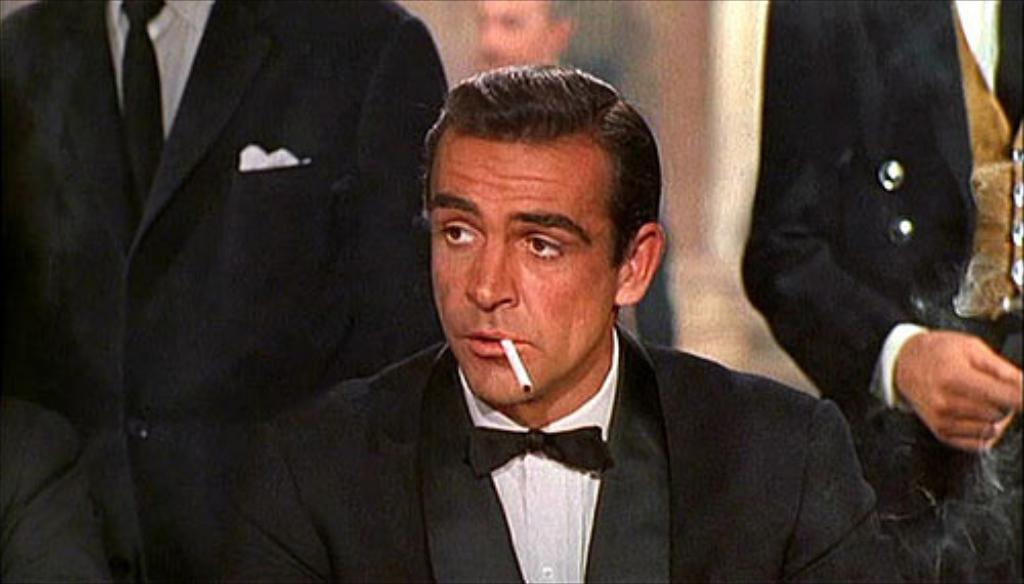What is the main subject of the image? There is a person in the image. What is the person doing in the image? The person is holding a cigarette with their mouth. Can you describe the background of the image? The background is blurry. Are there any other people visible in the image? Yes, there are other people in the background of the image. What type of square quilt is covering the dog in the image? There is no dog or quilt present in the image. 